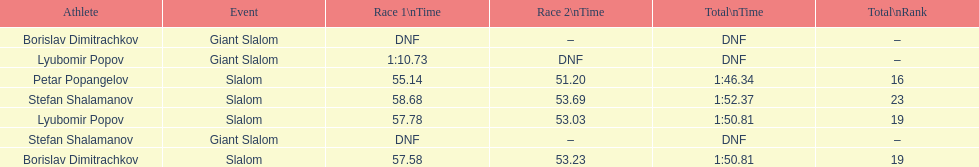Which athlete had a race time above 1:00? Lyubomir Popov. 